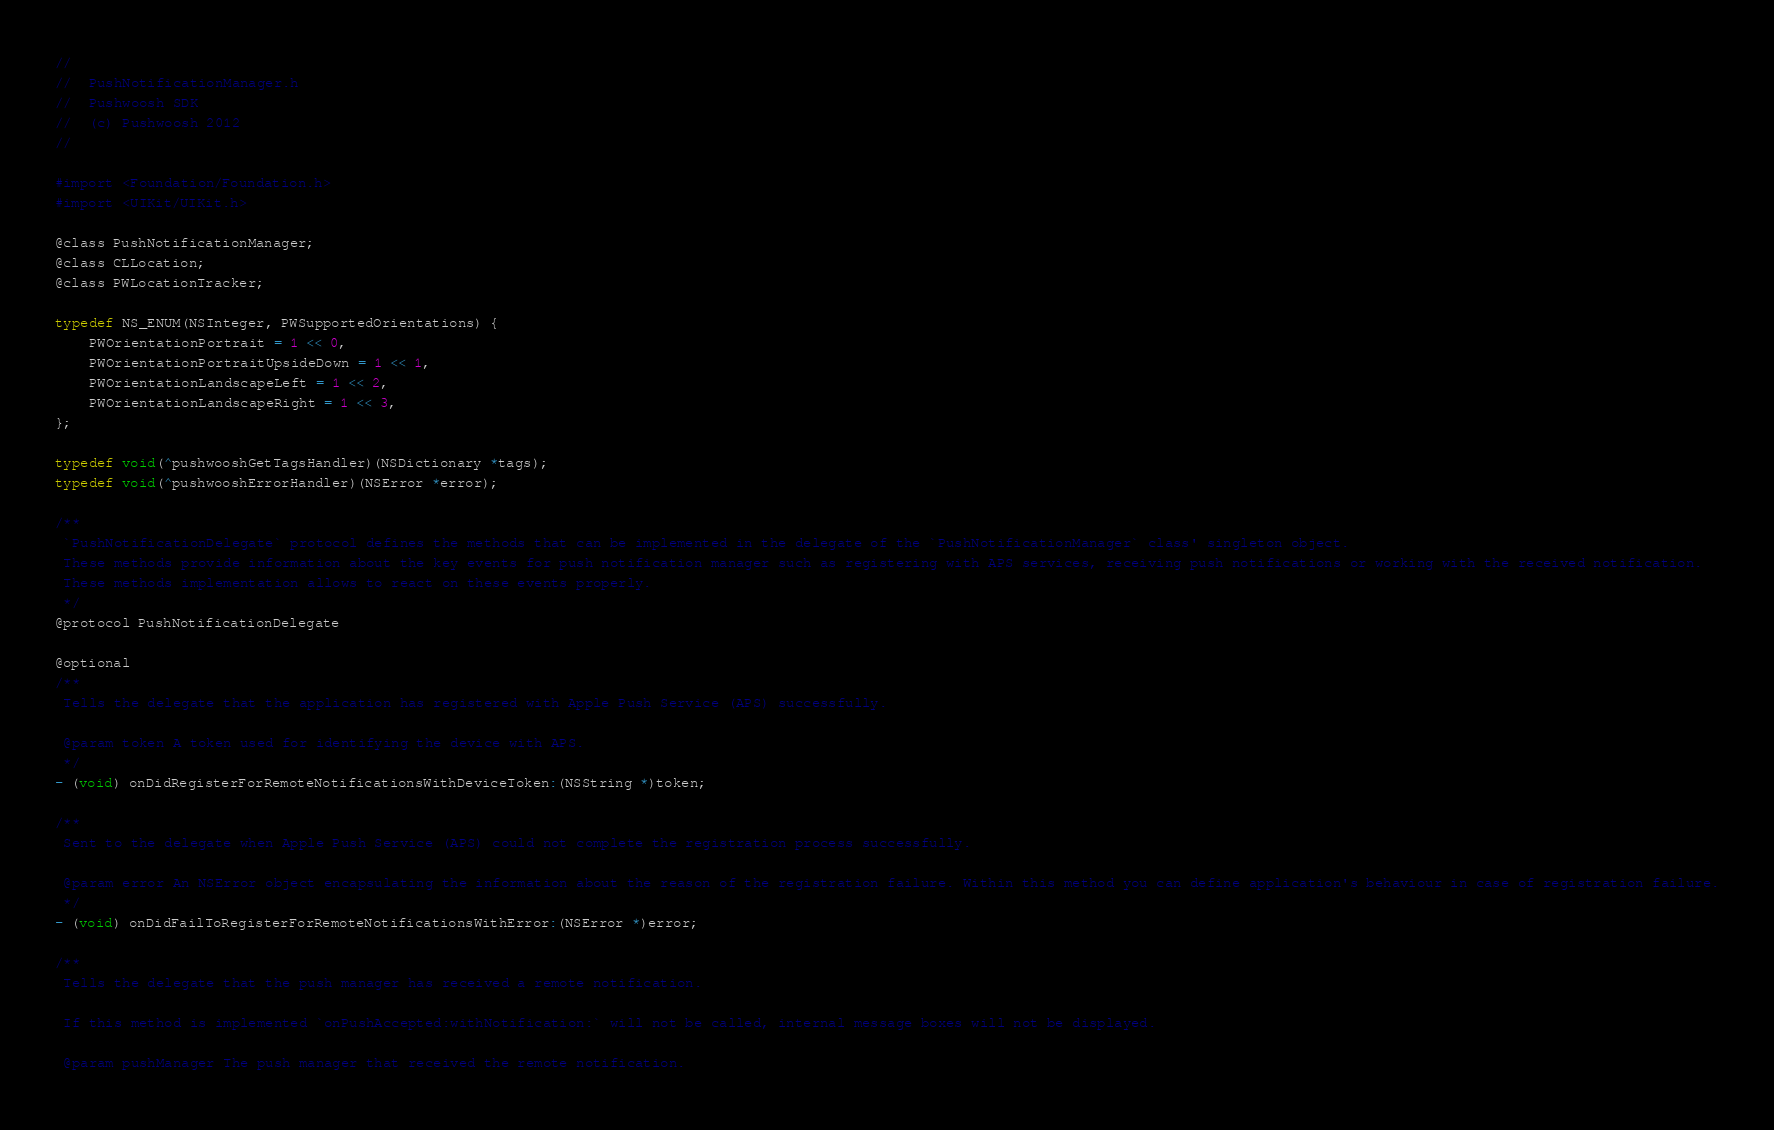Convert code to text. <code><loc_0><loc_0><loc_500><loc_500><_C_>//
//  PushNotificationManager.h
//  Pushwoosh SDK
//  (c) Pushwoosh 2012
//

#import <Foundation/Foundation.h>
#import <UIKit/UIKit.h>

@class PushNotificationManager;
@class CLLocation;
@class PWLocationTracker;

typedef NS_ENUM(NSInteger, PWSupportedOrientations) {
	PWOrientationPortrait = 1 << 0,
	PWOrientationPortraitUpsideDown = 1 << 1,
	PWOrientationLandscapeLeft = 1 << 2,
	PWOrientationLandscapeRight = 1 << 3,
};

typedef void(^pushwooshGetTagsHandler)(NSDictionary *tags);
typedef void(^pushwooshErrorHandler)(NSError *error);

/**
 `PushNotificationDelegate` protocol defines the methods that can be implemented in the delegate of the `PushNotificationManager` class' singleton object.
 These methods provide information about the key events for push notification manager such as registering with APS services, receiving push notifications or working with the received notification.
 These methods implementation allows to react on these events properly.
 */
@protocol PushNotificationDelegate

@optional
/**
 Tells the delegate that the application has registered with Apple Push Service (APS) successfully.
 
 @param token A token used for identifying the device with APS.
 */
- (void) onDidRegisterForRemoteNotificationsWithDeviceToken:(NSString *)token;

/**
 Sent to the delegate when Apple Push Service (APS) could not complete the registration process successfully.
 
 @param error An NSError object encapsulating the information about the reason of the registration failure. Within this method you can define application's behaviour in case of registration failure.
 */
- (void) onDidFailToRegisterForRemoteNotificationsWithError:(NSError *)error;

/**
 Tells the delegate that the push manager has received a remote notification.
 
 If this method is implemented `onPushAccepted:withNotification:` will not be called, internal message boxes will not be displayed.
 
 @param pushManager The push manager that received the remote notification.</code> 